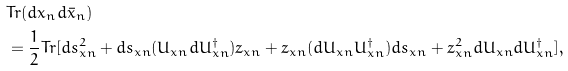Convert formula to latex. <formula><loc_0><loc_0><loc_500><loc_500>& T r ( d x _ { n } d \bar { x } _ { n } ) \\ & = \frac { 1 } { 2 } T r [ d s _ { x n } ^ { 2 } + d s _ { x n } ( U _ { x n } d U ^ { \dagger } _ { x n } ) z _ { x n } + z _ { x n } ( d U _ { x n } U ^ { \dagger } _ { x n } ) d s _ { x n } + z _ { x n } ^ { 2 } d U _ { x n } d U ^ { \dagger } _ { x n } ] ,</formula> 